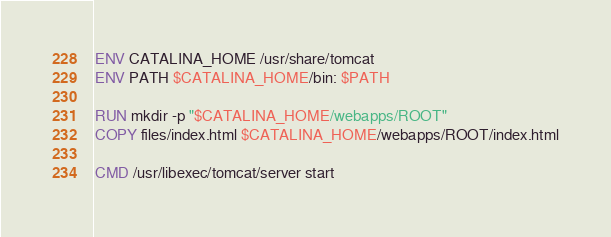Convert code to text. <code><loc_0><loc_0><loc_500><loc_500><_Dockerfile_>
ENV CATALINA_HOME /usr/share/tomcat
ENV PATH $CATALINA_HOME/bin: $PATH

RUN mkdir -p "$CATALINA_HOME/webapps/ROOT"
COPY files/index.html $CATALINA_HOME/webapps/ROOT/index.html

CMD /usr/libexec/tomcat/server start
</code> 